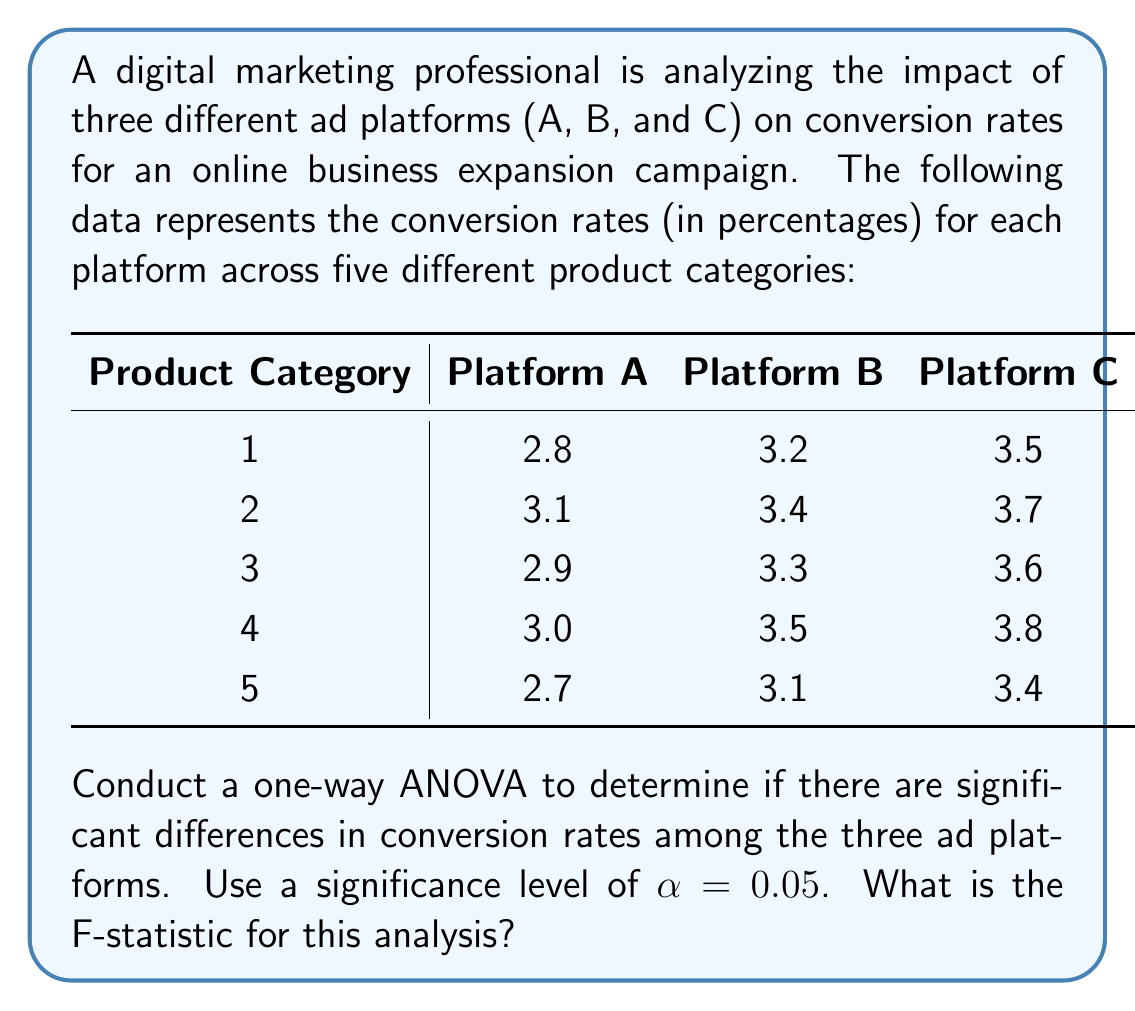Provide a solution to this math problem. To conduct a one-way ANOVA, we need to follow these steps:

1. Calculate the sum of squares between groups (SSB)
2. Calculate the sum of squares within groups (SSW)
3. Calculate the total sum of squares (SST)
4. Determine the degrees of freedom
5. Calculate the mean squares
6. Compute the F-statistic

Step 1: Calculate SSB

First, we need to find the grand mean and group means:

Grand mean: $\bar{X} = \frac{51}{15} = 3.4$

Group means:
Platform A: $\bar{X}_A = 2.9$
Platform B: $\bar{X}_B = 3.3$
Platform C: $\bar{X}_C = 3.6$

Now, we can calculate SSB:

$$\text{SSB} = n\sum_{i=1}^k (\bar{X}_i - \bar{X})^2$$

Where $n$ is the number of observations per group (5), and $k$ is the number of groups (3).

$$\text{SSB} = 5[(2.9 - 3.4)^2 + (3.3 - 3.4)^2 + (3.6 - 3.4)^2] = 1.05$$

Step 2: Calculate SSW

$$\text{SSW} = \sum_{i=1}^k \sum_{j=1}^n (X_{ij} - \bar{X}_i)^2$$

For Platform A: $0.04 + 0.04 + 0 + 0.01 + 0.04 = 0.13$
For Platform B: $0.01 + 0.01 + 0 + 0.04 + 0.04 = 0.10$
For Platform C: $0.01 + 0.01 + 0 + 0.04 + 0.04 = 0.10$

$$\text{SSW} = 0.13 + 0.10 + 0.10 = 0.33$$

Step 3: Calculate SST

$$\text{SST} = \text{SSB} + \text{SSW} = 1.05 + 0.33 = 1.38$$

Step 4: Determine degrees of freedom

Between groups: $df_B = k - 1 = 3 - 1 = 2$
Within groups: $df_W = N - k = 15 - 3 = 12$
Total: $df_T = N - 1 = 15 - 1 = 14$

Step 5: Calculate mean squares

$$\text{MSB} = \frac{\text{SSB}}{df_B} = \frac{1.05}{2} = 0.525$$
$$\text{MSW} = \frac{\text{SSW}}{df_W} = \frac{0.33}{12} = 0.0275$$

Step 6: Compute the F-statistic

$$F = \frac{\text{MSB}}{\text{MSW}} = \frac{0.525}{0.0275} = 19.09$$
Answer: The F-statistic for this one-way ANOVA analysis is 19.09. 